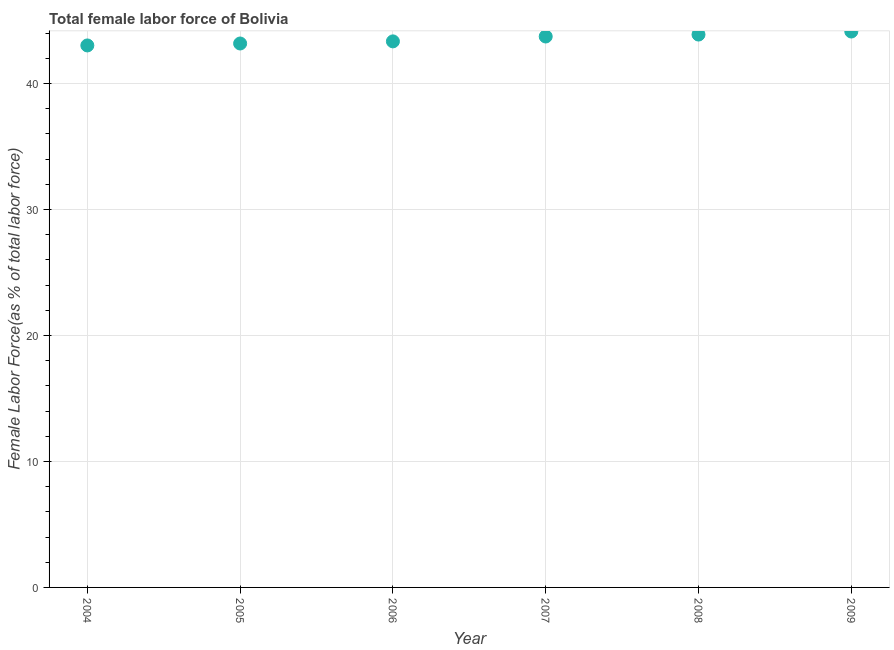What is the total female labor force in 2005?
Offer a terse response. 43.18. Across all years, what is the maximum total female labor force?
Offer a very short reply. 44.13. Across all years, what is the minimum total female labor force?
Provide a succinct answer. 43.03. In which year was the total female labor force minimum?
Give a very brief answer. 2004. What is the sum of the total female labor force?
Your answer should be compact. 261.31. What is the difference between the total female labor force in 2007 and 2008?
Ensure brevity in your answer.  -0.15. What is the average total female labor force per year?
Your answer should be compact. 43.55. What is the median total female labor force?
Ensure brevity in your answer.  43.54. Do a majority of the years between 2009 and 2007 (inclusive) have total female labor force greater than 36 %?
Offer a very short reply. No. What is the ratio of the total female labor force in 2007 to that in 2008?
Give a very brief answer. 1. Is the total female labor force in 2008 less than that in 2009?
Give a very brief answer. Yes. Is the difference between the total female labor force in 2004 and 2007 greater than the difference between any two years?
Your answer should be very brief. No. What is the difference between the highest and the second highest total female labor force?
Your response must be concise. 0.24. Is the sum of the total female labor force in 2006 and 2009 greater than the maximum total female labor force across all years?
Make the answer very short. Yes. What is the difference between the highest and the lowest total female labor force?
Keep it short and to the point. 1.11. Does the total female labor force monotonically increase over the years?
Offer a terse response. Yes. Does the graph contain any zero values?
Make the answer very short. No. Does the graph contain grids?
Provide a succinct answer. Yes. What is the title of the graph?
Make the answer very short. Total female labor force of Bolivia. What is the label or title of the X-axis?
Offer a very short reply. Year. What is the label or title of the Y-axis?
Provide a succinct answer. Female Labor Force(as % of total labor force). What is the Female Labor Force(as % of total labor force) in 2004?
Keep it short and to the point. 43.03. What is the Female Labor Force(as % of total labor force) in 2005?
Give a very brief answer. 43.18. What is the Female Labor Force(as % of total labor force) in 2006?
Your response must be concise. 43.35. What is the Female Labor Force(as % of total labor force) in 2007?
Ensure brevity in your answer.  43.74. What is the Female Labor Force(as % of total labor force) in 2008?
Your response must be concise. 43.89. What is the Female Labor Force(as % of total labor force) in 2009?
Give a very brief answer. 44.13. What is the difference between the Female Labor Force(as % of total labor force) in 2004 and 2005?
Your answer should be compact. -0.15. What is the difference between the Female Labor Force(as % of total labor force) in 2004 and 2006?
Ensure brevity in your answer.  -0.32. What is the difference between the Female Labor Force(as % of total labor force) in 2004 and 2007?
Your answer should be very brief. -0.71. What is the difference between the Female Labor Force(as % of total labor force) in 2004 and 2008?
Offer a very short reply. -0.86. What is the difference between the Female Labor Force(as % of total labor force) in 2004 and 2009?
Provide a short and direct response. -1.11. What is the difference between the Female Labor Force(as % of total labor force) in 2005 and 2006?
Provide a short and direct response. -0.17. What is the difference between the Female Labor Force(as % of total labor force) in 2005 and 2007?
Offer a very short reply. -0.55. What is the difference between the Female Labor Force(as % of total labor force) in 2005 and 2008?
Provide a succinct answer. -0.71. What is the difference between the Female Labor Force(as % of total labor force) in 2005 and 2009?
Provide a succinct answer. -0.95. What is the difference between the Female Labor Force(as % of total labor force) in 2006 and 2007?
Your response must be concise. -0.39. What is the difference between the Female Labor Force(as % of total labor force) in 2006 and 2008?
Provide a short and direct response. -0.54. What is the difference between the Female Labor Force(as % of total labor force) in 2006 and 2009?
Ensure brevity in your answer.  -0.78. What is the difference between the Female Labor Force(as % of total labor force) in 2007 and 2008?
Offer a very short reply. -0.15. What is the difference between the Female Labor Force(as % of total labor force) in 2007 and 2009?
Offer a very short reply. -0.4. What is the difference between the Female Labor Force(as % of total labor force) in 2008 and 2009?
Your answer should be compact. -0.24. What is the ratio of the Female Labor Force(as % of total labor force) in 2004 to that in 2007?
Your answer should be compact. 0.98. What is the ratio of the Female Labor Force(as % of total labor force) in 2004 to that in 2009?
Your answer should be very brief. 0.97. What is the ratio of the Female Labor Force(as % of total labor force) in 2005 to that in 2007?
Provide a succinct answer. 0.99. What is the ratio of the Female Labor Force(as % of total labor force) in 2005 to that in 2008?
Keep it short and to the point. 0.98. What is the ratio of the Female Labor Force(as % of total labor force) in 2006 to that in 2007?
Offer a terse response. 0.99. What is the ratio of the Female Labor Force(as % of total labor force) in 2007 to that in 2008?
Offer a very short reply. 1. What is the ratio of the Female Labor Force(as % of total labor force) in 2007 to that in 2009?
Ensure brevity in your answer.  0.99. 